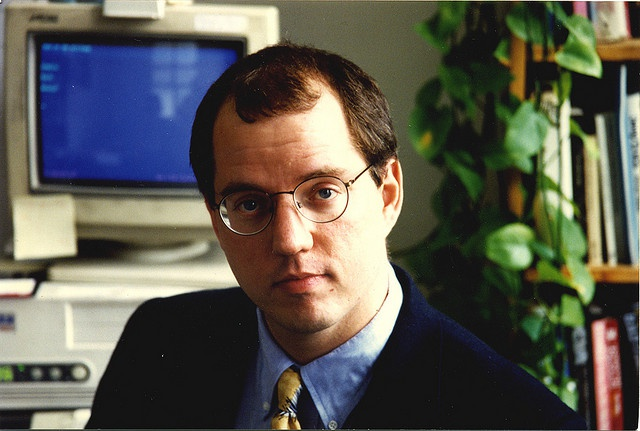Describe the objects in this image and their specific colors. I can see people in white, black, beige, maroon, and tan tones, tv in white, darkblue, blue, black, and navy tones, book in white, lightpink, brown, black, and maroon tones, book in white, black, khaki, tan, and olive tones, and book in white, darkgray, beige, black, and gray tones in this image. 